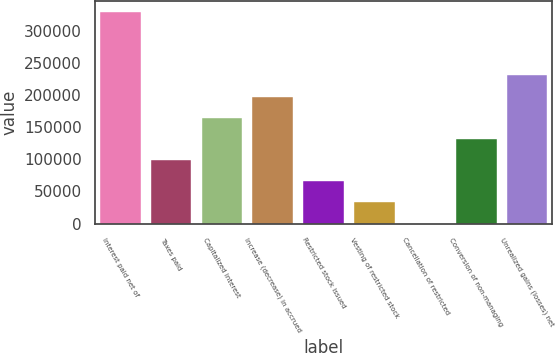Convert chart to OTSL. <chart><loc_0><loc_0><loc_500><loc_500><bar_chart><fcel>Interest paid net of<fcel>Taxes paid<fcel>Capitalized interest<fcel>Increase (decrease) in accrued<fcel>Restricted stock issued<fcel>Vesting of restricted stock<fcel>Cancellation of restricted<fcel>Conversion of non-managing<fcel>Unrealized gains (losses) net<nl><fcel>329679<fcel>98932.4<fcel>164860<fcel>197824<fcel>65968.6<fcel>33004.8<fcel>41<fcel>131896<fcel>230788<nl></chart> 